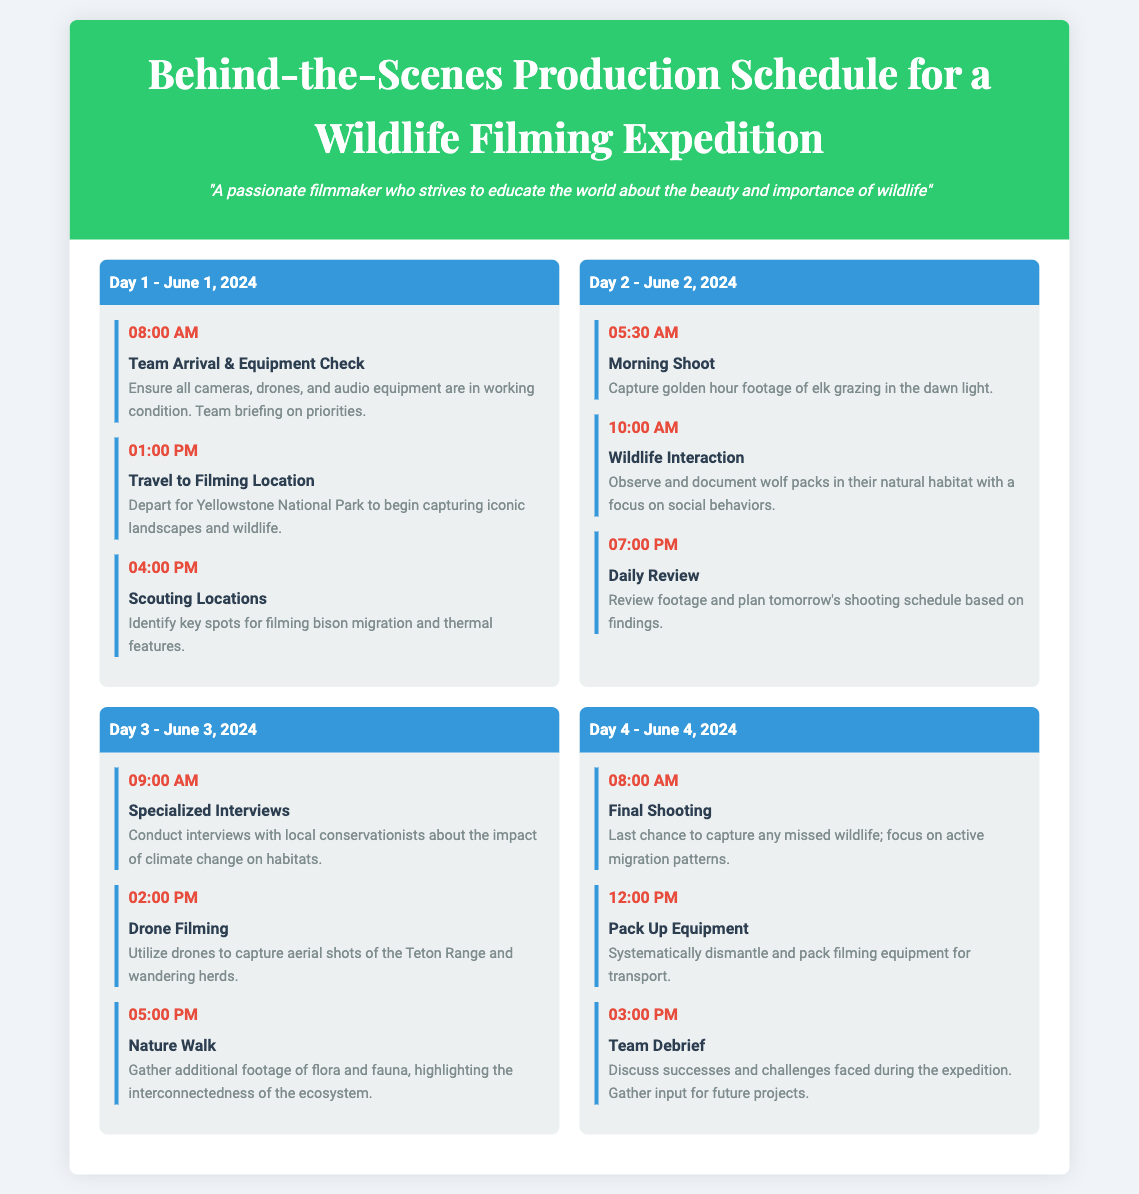What is the start date of the filming expedition? The start date is mentioned in the document as June 1, 2024.
Answer: June 1, 2024 How many days is the filming expedition scheduled for? The document outlines activities for four days, from June 1 to June 4, 2024.
Answer: Four days What is the first activity scheduled for Day 2? The first activity listed for Day 2 is the Morning Shoot at 5:30 AM.
Answer: Morning Shoot On which day is the Team Debrief planned? The Team Debrief occurs on Day 4, which is June 4, 2024.
Answer: June 4, 2024 What time is the Final Shooting scheduled for? The Final Shooting is scheduled for 8:00 AM on Day 4.
Answer: 8:00 AM Which wildlife will be the focus of the drone filming? The drone filming focuses on the Teton Range and wandering herds.
Answer: Teton Range and wandering herds What type of equipment will be checked on Day 1? The equipment mentioned for checking includes cameras, drones, and audio equipment.
Answer: Cameras, drones, and audio equipment Which animal species' behavior is the focus during the Wildlife Interaction activity? The focus is on wolf packs and their social behaviors during Wildlife Interaction.
Answer: Wolf packs 